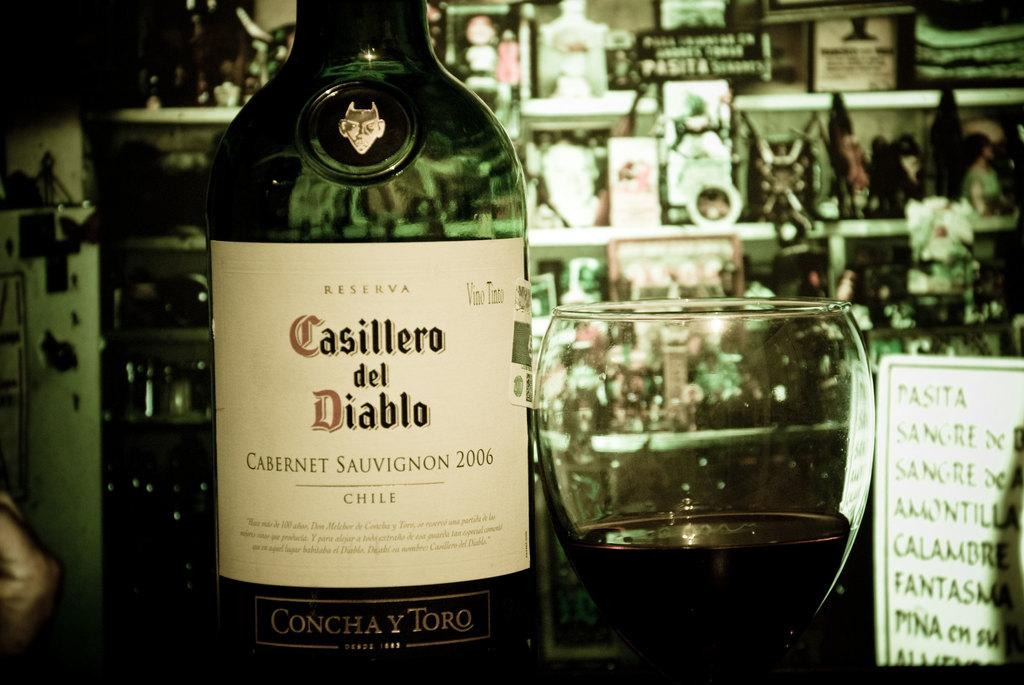<image>
Present a compact description of the photo's key features. A green bottle of Casillero del Diablo wine is shown up close. 